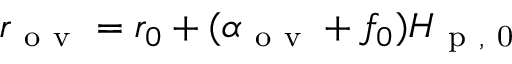<formula> <loc_0><loc_0><loc_500><loc_500>r _ { o v } = r _ { 0 } + ( \alpha _ { o v } + f _ { 0 } ) H _ { p , 0 }</formula> 